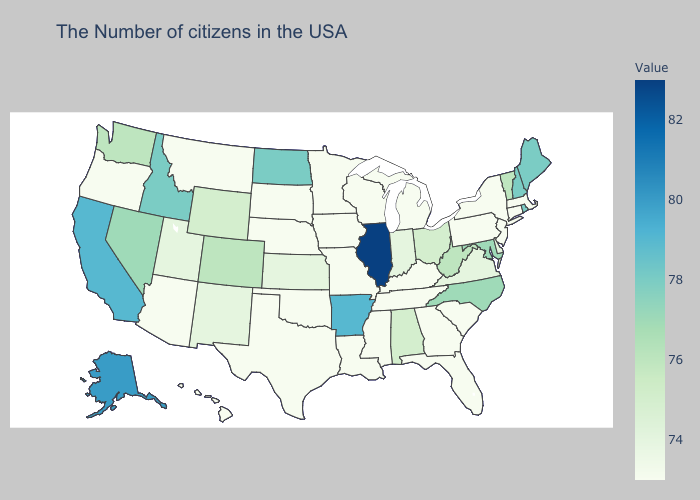Among the states that border Missouri , which have the highest value?
Short answer required. Illinois. Which states have the highest value in the USA?
Short answer required. Illinois. Does Nebraska have the highest value in the USA?
Be succinct. No. Does Illinois have the lowest value in the USA?
Keep it brief. No. 